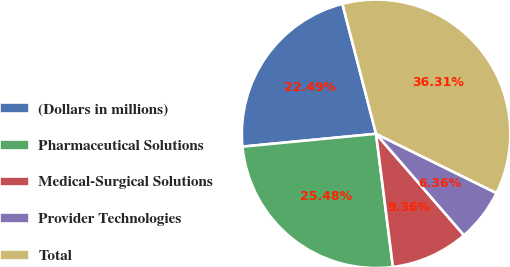<chart> <loc_0><loc_0><loc_500><loc_500><pie_chart><fcel>(Dollars in millions)<fcel>Pharmaceutical Solutions<fcel>Medical-Surgical Solutions<fcel>Provider Technologies<fcel>Total<nl><fcel>22.49%<fcel>25.48%<fcel>9.36%<fcel>6.36%<fcel>36.31%<nl></chart> 